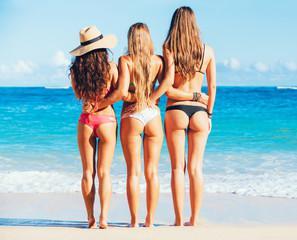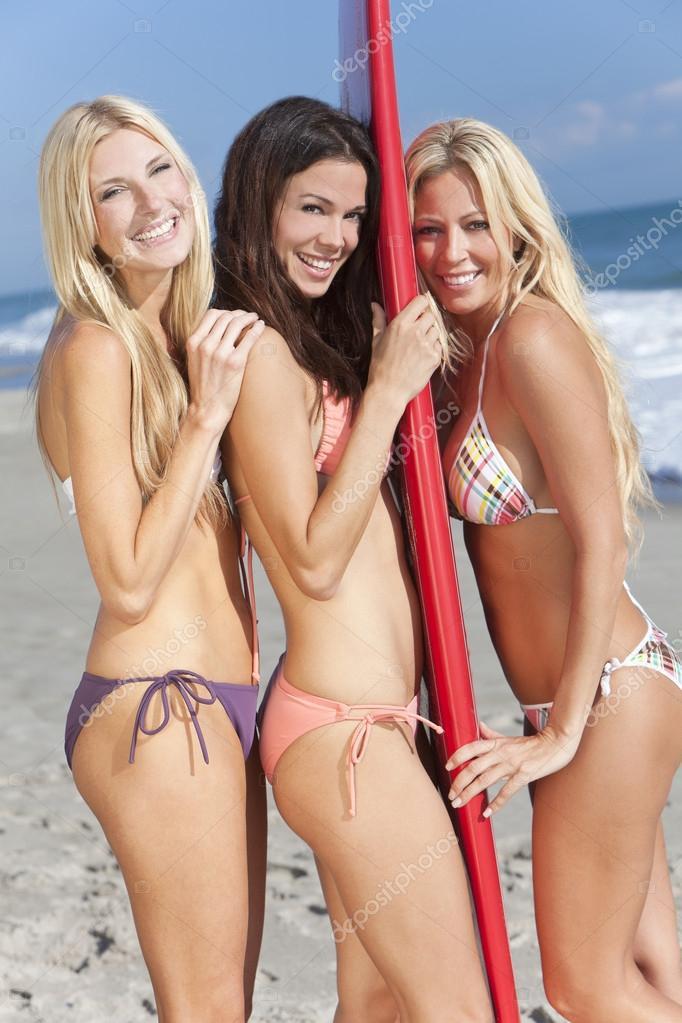The first image is the image on the left, the second image is the image on the right. Evaluate the accuracy of this statement regarding the images: "Three women have their backs at the camera.". Is it true? Answer yes or no. Yes. The first image is the image on the left, the second image is the image on the right. Assess this claim about the two images: "Three models pose with rears turned to the camera in one image.". Correct or not? Answer yes or no. Yes. 